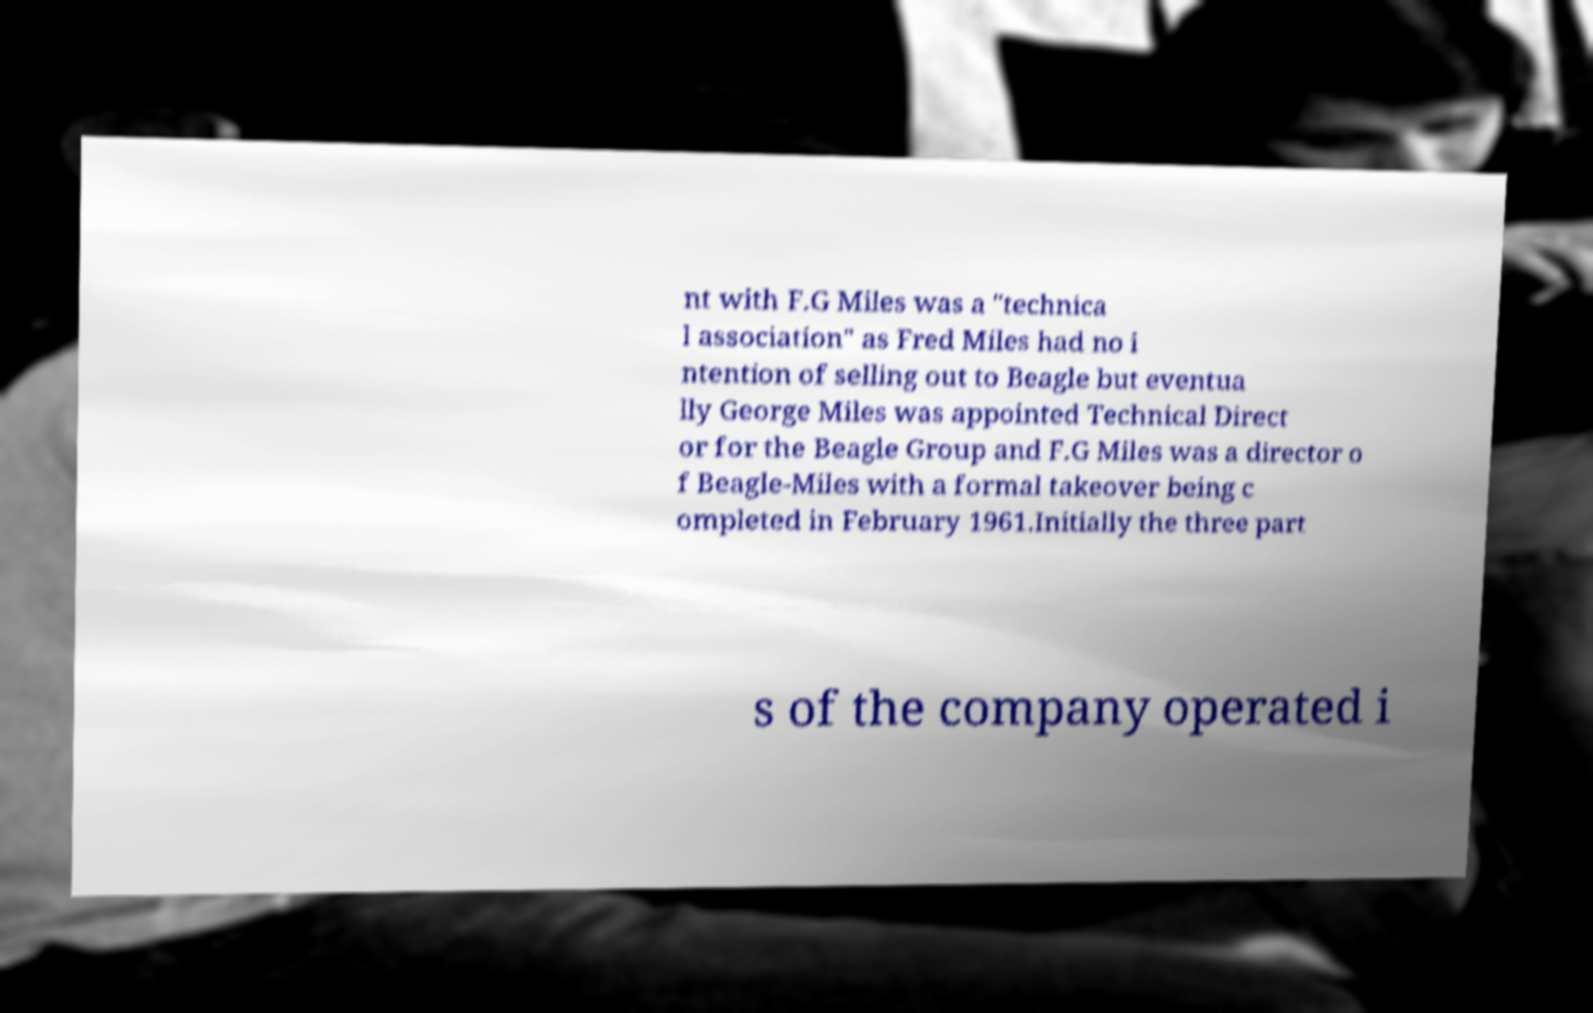What messages or text are displayed in this image? I need them in a readable, typed format. nt with F.G Miles was a "technica l association" as Fred Miles had no i ntention of selling out to Beagle but eventua lly George Miles was appointed Technical Direct or for the Beagle Group and F.G Miles was a director o f Beagle-Miles with a formal takeover being c ompleted in February 1961.Initially the three part s of the company operated i 